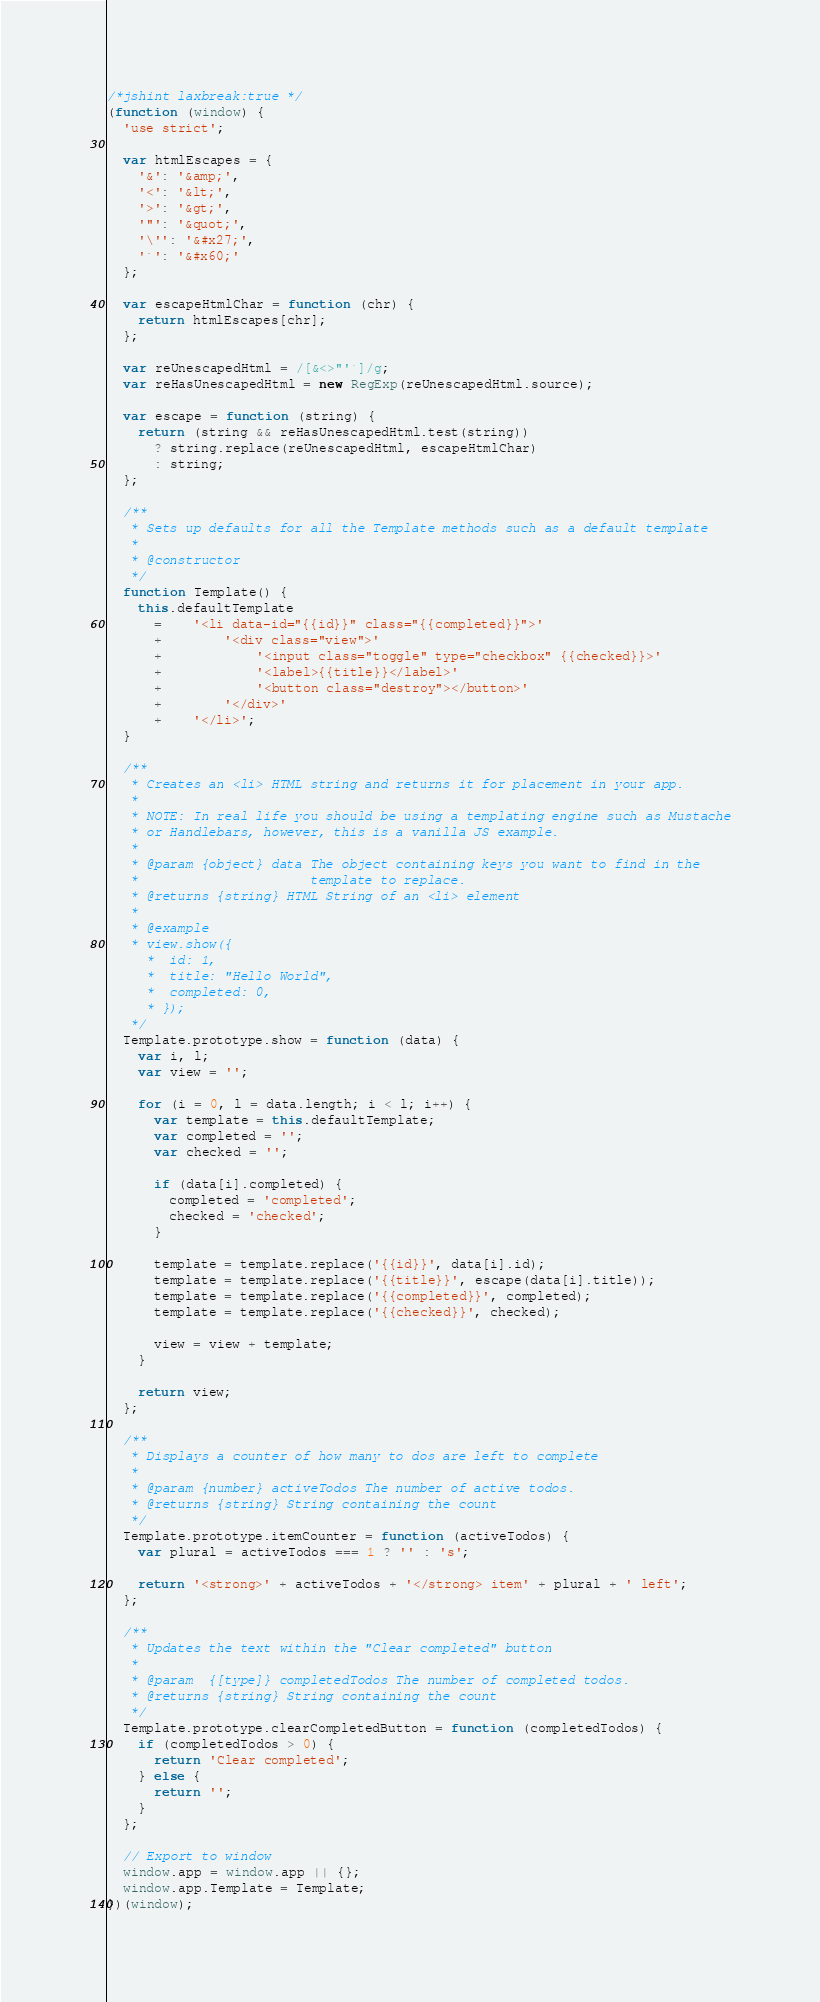Convert code to text. <code><loc_0><loc_0><loc_500><loc_500><_JavaScript_>/*jshint laxbreak:true */
(function (window) {
  'use strict';

  var htmlEscapes = {
    '&': '&amp;',
    '<': '&lt;',
    '>': '&gt;',
    '"': '&quot;',
    '\'': '&#x27;',
    '`': '&#x60;'
  };

  var escapeHtmlChar = function (chr) {
    return htmlEscapes[chr];
  };

  var reUnescapedHtml = /[&<>"'`]/g;
  var reHasUnescapedHtml = new RegExp(reUnescapedHtml.source);

  var escape = function (string) {
    return (string && reHasUnescapedHtml.test(string))
      ? string.replace(reUnescapedHtml, escapeHtmlChar)
      : string;
  };

  /**
   * Sets up defaults for all the Template methods such as a default template
   *
   * @constructor
   */
  function Template() {
    this.defaultTemplate
      =	'<li data-id="{{id}}" class="{{completed}}">'
      +		'<div class="view">'
      +			'<input class="toggle" type="checkbox" {{checked}}>'
      +			'<label>{{title}}</label>'
      +			'<button class="destroy"></button>'
      +		'</div>'
      +	'</li>';
  }

  /**
   * Creates an <li> HTML string and returns it for placement in your app.
   *
   * NOTE: In real life you should be using a templating engine such as Mustache
   * or Handlebars, however, this is a vanilla JS example.
   *
   * @param {object} data The object containing keys you want to find in the
   *                      template to replace.
   * @returns {string} HTML String of an <li> element
   *
   * @example
   * view.show({
	 *	id: 1,
	 *	title: "Hello World",
	 *	completed: 0,
	 * });
   */
  Template.prototype.show = function (data) {
    var i, l;
    var view = '';

    for (i = 0, l = data.length; i < l; i++) {
      var template = this.defaultTemplate;
      var completed = '';
      var checked = '';

      if (data[i].completed) {
        completed = 'completed';
        checked = 'checked';
      }

      template = template.replace('{{id}}', data[i].id);
      template = template.replace('{{title}}', escape(data[i].title));
      template = template.replace('{{completed}}', completed);
      template = template.replace('{{checked}}', checked);

      view = view + template;
    }

    return view;
  };

  /**
   * Displays a counter of how many to dos are left to complete
   *
   * @param {number} activeTodos The number of active todos.
   * @returns {string} String containing the count
   */
  Template.prototype.itemCounter = function (activeTodos) {
    var plural = activeTodos === 1 ? '' : 's';

    return '<strong>' + activeTodos + '</strong> item' + plural + ' left';
  };

  /**
   * Updates the text within the "Clear completed" button
   *
   * @param  {[type]} completedTodos The number of completed todos.
   * @returns {string} String containing the count
   */
  Template.prototype.clearCompletedButton = function (completedTodos) {
    if (completedTodos > 0) {
      return 'Clear completed';
    } else {
      return '';
    }
  };

  // Export to window
  window.app = window.app || {};
  window.app.Template = Template;
})(window);</code> 